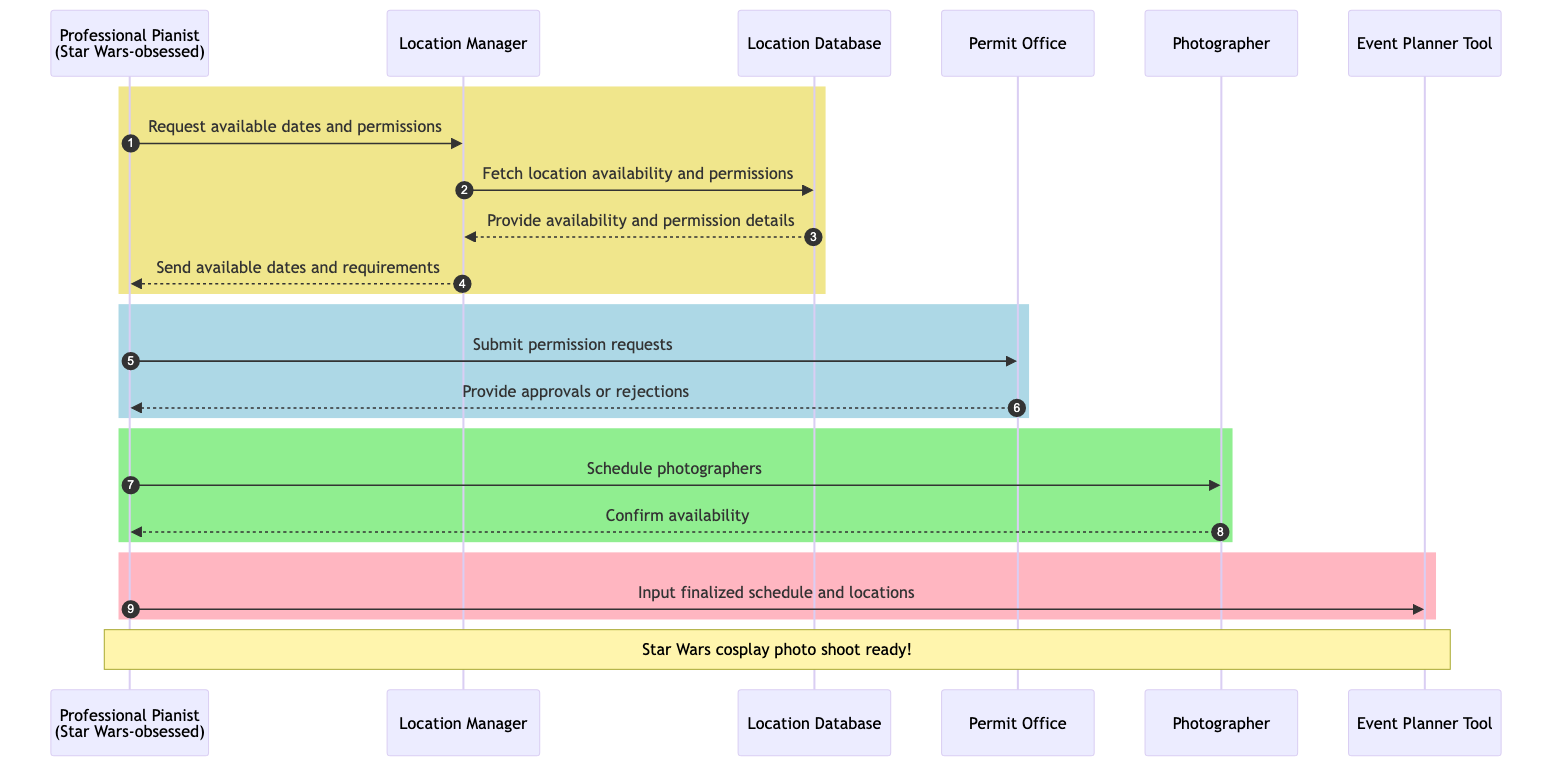What is the first action taken by the Professional Pianist? The first action shown in the diagram is the Professional Pianist requesting available dates and permissions from the Location Manager. This initiates the process of organizing the photo shoot.
Answer: Request available dates and permissions How many external systems are involved in the process? The diagram identifies three external systems: the Photographer, the Location Manager, and the Permit Office. Counting these gives the total number of external systems involved.
Answer: 3 Which system does the Location Manager communicate with to fetch location availability? The diagram specifies that the Location Manager communicates with the Location Database to fetch availability and permission details, depicting the interaction necessary for the planning process.
Answer: Location Database What is the final system that the Professional Pianist inputs the finalized schedule into? The diagram indicates that the Professional Pianist inputs the finalized schedule and locations into the Event Planner Tool as the last action in the sequence, completing the planning process.
Answer: Event Planner Tool What happens after the Photographer confirms availability? After the Photographer confirms availability, the Professional Pianist proceeds to input the finalized schedule and locations into the Event Planner Tool, showing the continuation of the planning process based on the confirmation received.
Answer: Input finalized schedule and locations What is the role of the Permit Office in this diagram? The Permit Office processes the permission requests submitted by the Professional Pianist and provides either approvals or rejections based on those requests. This interaction is critical for ensuring the shoot can proceed at selected locations.
Answer: Provide approvals or rejections What color rectangle represents scheduling photographers? The scheduling photographers action is contained within a light green rectangle defined in the diagram, visually indicating this specific phase of the process concerning securing the photographer’s participation.
Answer: Light green How does the process start and end in this sequence diagram? The process starts with the Professional Pianist requesting available dates and permissions and ends with the Input finalized schedule and locations, demonstrating a clear flow from initiation to conclusion in organizing the photo shoot.
Answer: Start: Request available dates; End: Input finalized schedule and locations 